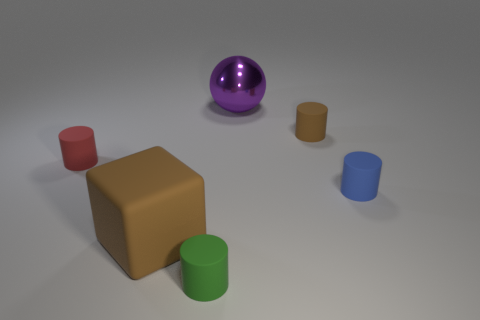Subtract 1 cylinders. How many cylinders are left? 3 Add 4 tiny brown rubber cylinders. How many objects exist? 10 Subtract all balls. How many objects are left? 5 Add 5 blue cylinders. How many blue cylinders are left? 6 Add 2 small gray cubes. How many small gray cubes exist? 2 Subtract 0 purple blocks. How many objects are left? 6 Subtract all green rubber cylinders. Subtract all small brown cylinders. How many objects are left? 4 